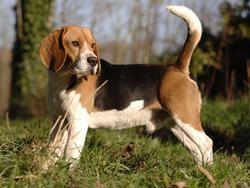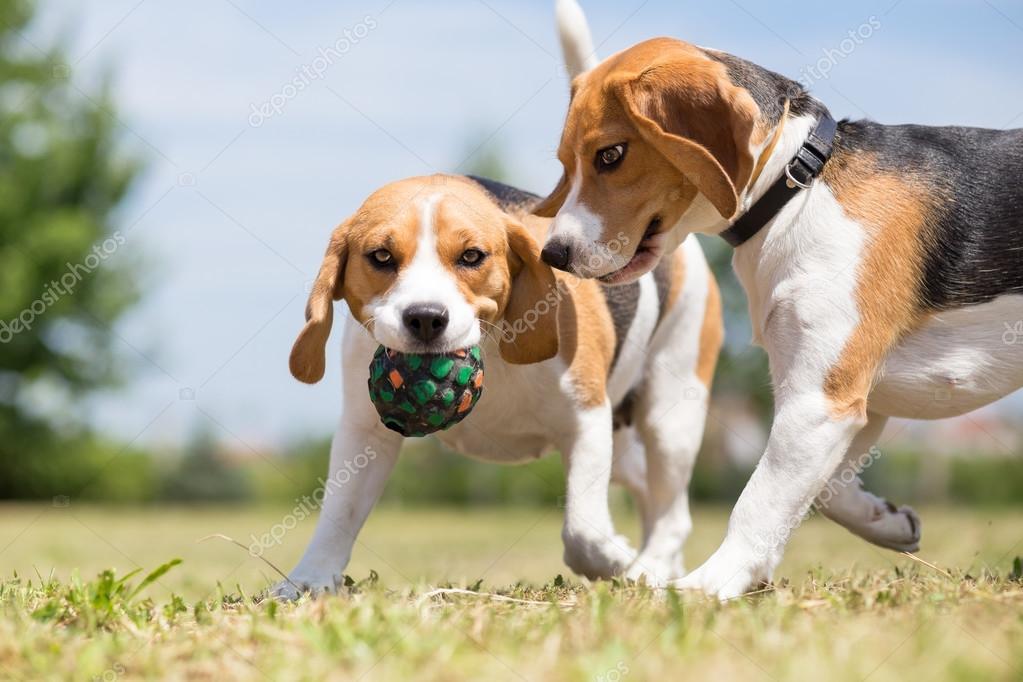The first image is the image on the left, the second image is the image on the right. Assess this claim about the two images: "A dog in one image has a toy in his mouth.". Correct or not? Answer yes or no. Yes. 